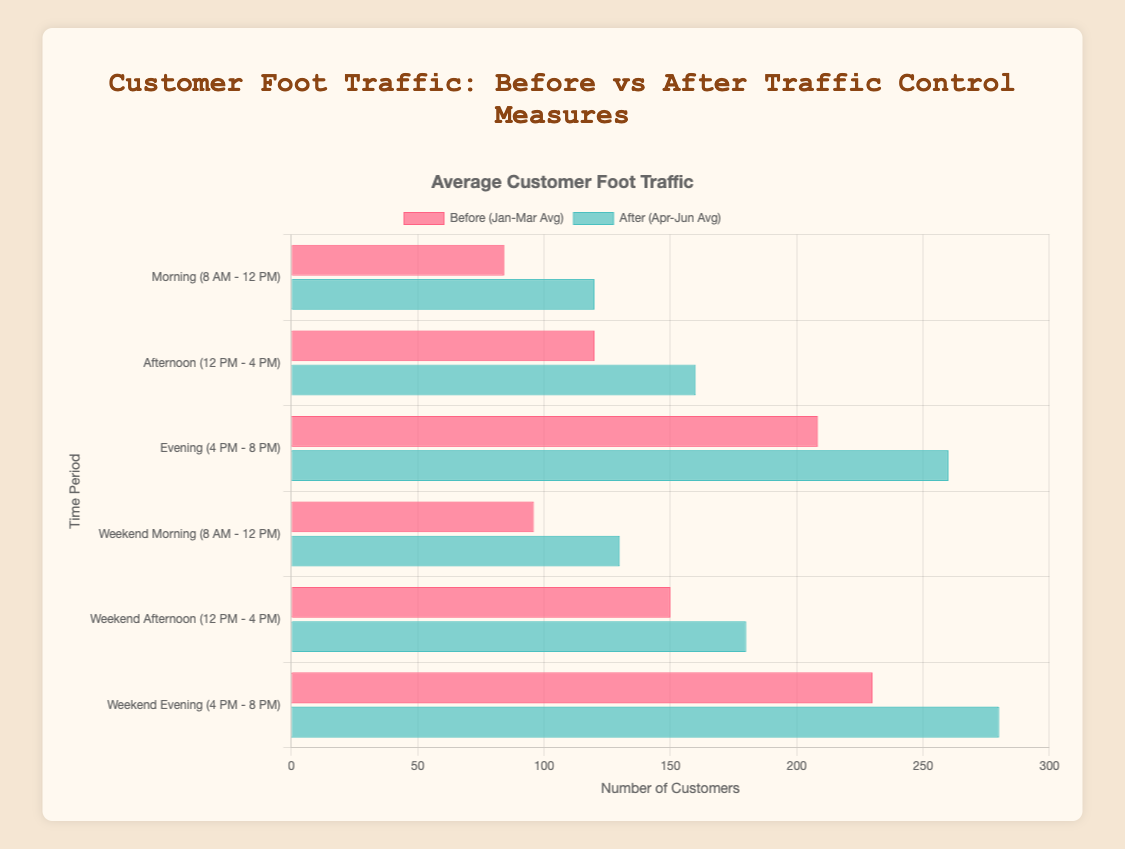What is the average customer foot traffic before and after the implementation of traffic control measures in the evening time on weekends? First, find the average foot traffic for the weekend evening in the three months before the measures: (220 + 230 + 240) / 3 = 230. Next, find the average for the three months after: (270 + 280 + 290) / 3 = 280. Finally, compare the two averages.
Answer: Before: 230, After: 280 Which time period experienced the highest increase in customer foot traffic following the implementation of traffic control measures? Calculate the difference in foot traffic for each time period: Morning: 120 - 84.3 = 35.7, Afternoon: 160 - 120 = 40, Evening: 260 - 208.3 = 51.7, Weekend Morning: 130 - 96 = 34, Weekend Afternoon: 180 - 150 = 30, Weekend Evening: 280 - 230 = 50. The evening time period has the highest increase.
Answer: Evening (51.7) During which time frame were the traffic measures most effective, resulting in the highest customer foot traffic? Compare the average foot traffic after the measures across all time periods. The highest average foot traffic after the measures is in the weekend evening (280).
Answer: Weekend Evening (280) How does customer foot traffic during weekday mornings compare to weekend mornings after traffic control measures? Look at the foot traffic for weekday mornings (120) and weekend mornings (130) after the measures. The traffic on weekend mornings is higher.
Answer: Weekend mornings have higher traffic (130 vs. 120) What is the difference in foot traffic on weekday afternoons before and after the implementation of traffic control measures? Find the average foot traffic for weekday afternoons before (110 + 120 + 130) / 3 = 120. Determine the foot traffic after (160). Subtract the before value from the after value (160 - 120 = 40).
Answer: 40 Which part of the week (weekday or weekend) saw greater improvement in customer foot traffic after implementing traffic control measures in the afternoon period? Calculate the improvement for the weekday afternoon: 160 (after) - 120 (before) = 40. For the weekend afternoon: 180 (after) - 150 (before) = 30. Weekdays saw a greater improvement.
Answer: Weekdays (40) In which time period do we see the closest foot traffic values before and after implementing traffic control measures? Calculate the absolute difference for each time period: Morning: 35.7, Afternoon: 40, Evening: 51.7, Weekend Morning: 34, Weekend Afternoon: 30, Weekend Evening: 50. The weekend afternoon has the smallest difference of 30.
Answer: Weekend Afternoon (30) What is the overall average customer foot traffic across all time periods before the traffic control measures? Sum the foot traffic for all periods in January, February, and March: (85 + 120 + 200 + 90 + 150 + 220) + (88 + 110 + 210 + 100 + 140 + 230) + (80 + 130 + 215 + 98 + 160 + 240) = 3121. Divide by the total number of data points (18): 3121 / 18 ≈ 173.4
Answer: 173.4 What is the percentage increase in customer foot traffic from before to after the implementation of traffic control measures for the afternoon time on weekdays? Average foot traffic before: 120, after: 160. The percentage increase is ((160 - 120) / 120) * 100 ≈ 33.3%.
Answer: 33.3% How does the visual representation of the after data compare to the before data in general? The bars representing customer foot traffic after the measures are consistently longer than those before. They are also colored in shades of blue compared to the red shades before.
Answer: After bars are longer and blue 